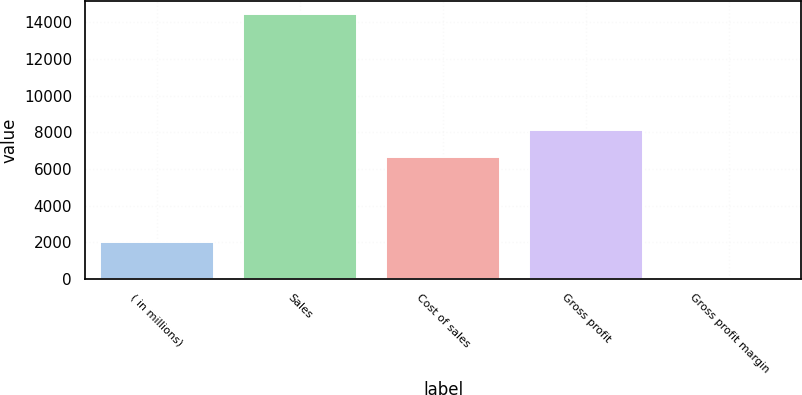<chart> <loc_0><loc_0><loc_500><loc_500><bar_chart><fcel>( in millions)<fcel>Sales<fcel>Cost of sales<fcel>Gross profit<fcel>Gross profit margin<nl><fcel>2015<fcel>14433.7<fcel>6662.6<fcel>8100.59<fcel>53.8<nl></chart> 